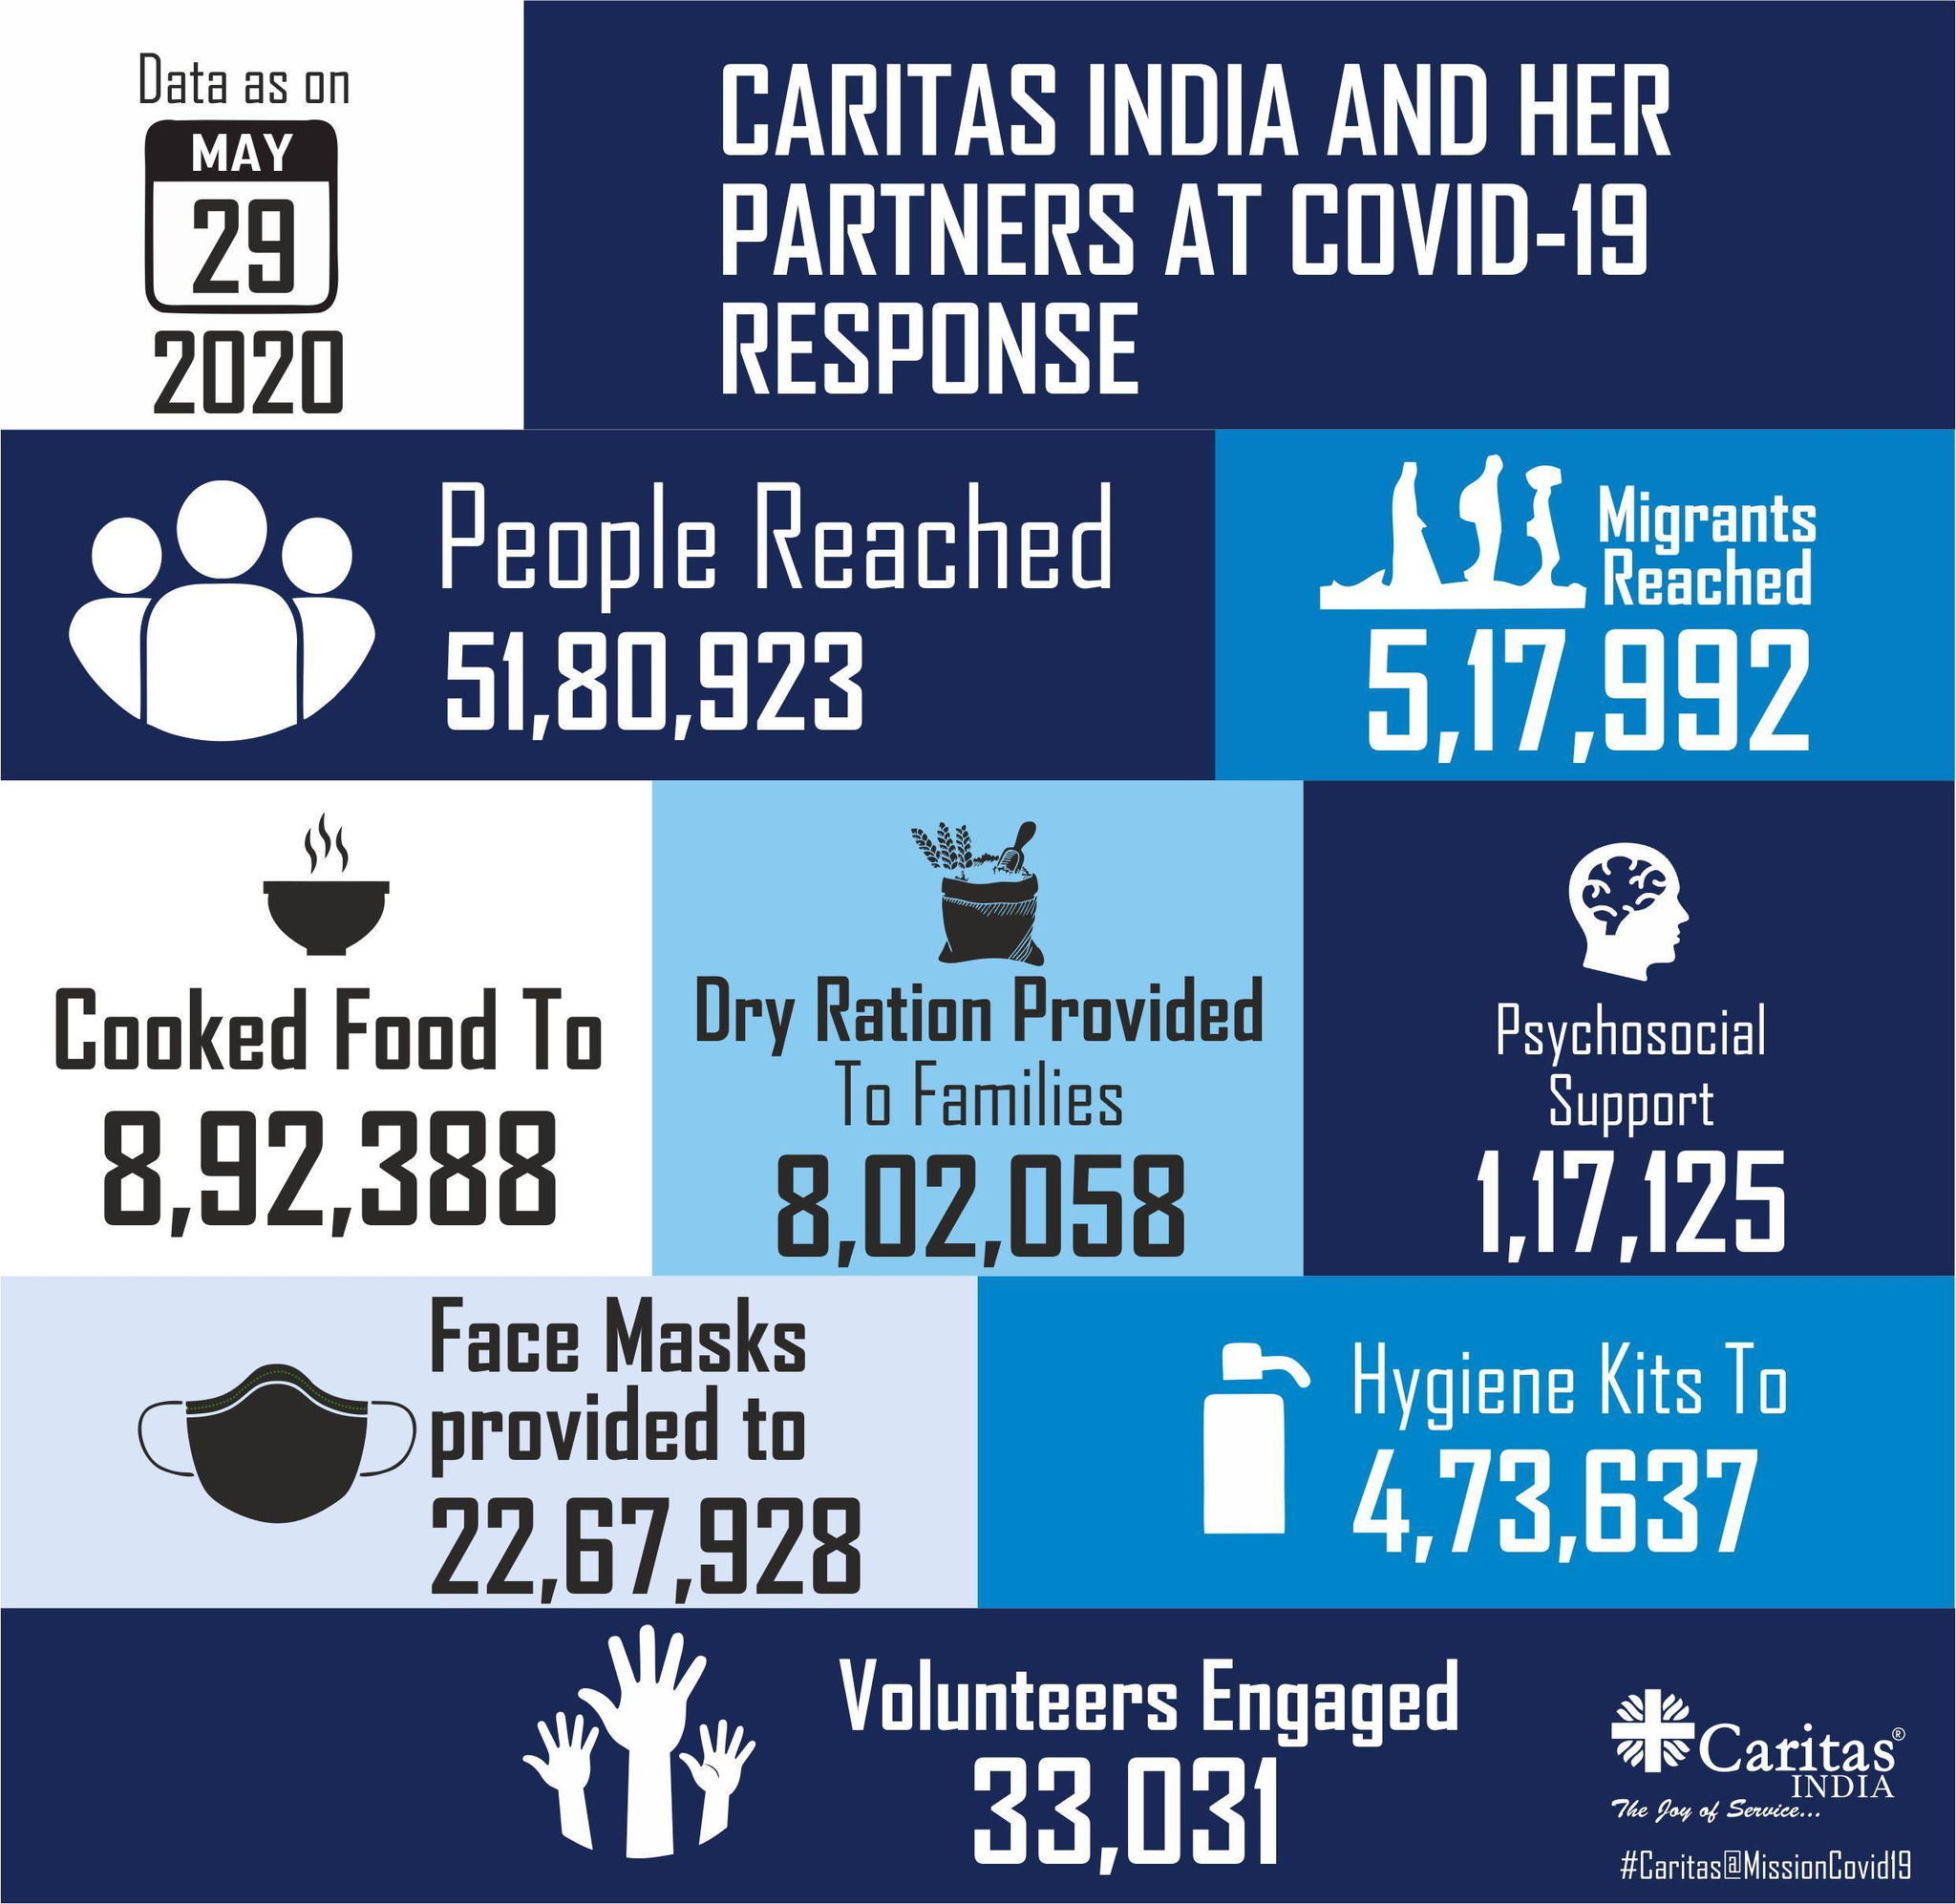How many migrants reached India as on May 29, 2020?
Answer the question with a short phrase. 5,17,992 What is the number of dry ration provided to the families in India as on May 29, 2020? 8,02,058 How many people in India were given Psychosocial support as on May 29, 2020? 1,17,125 